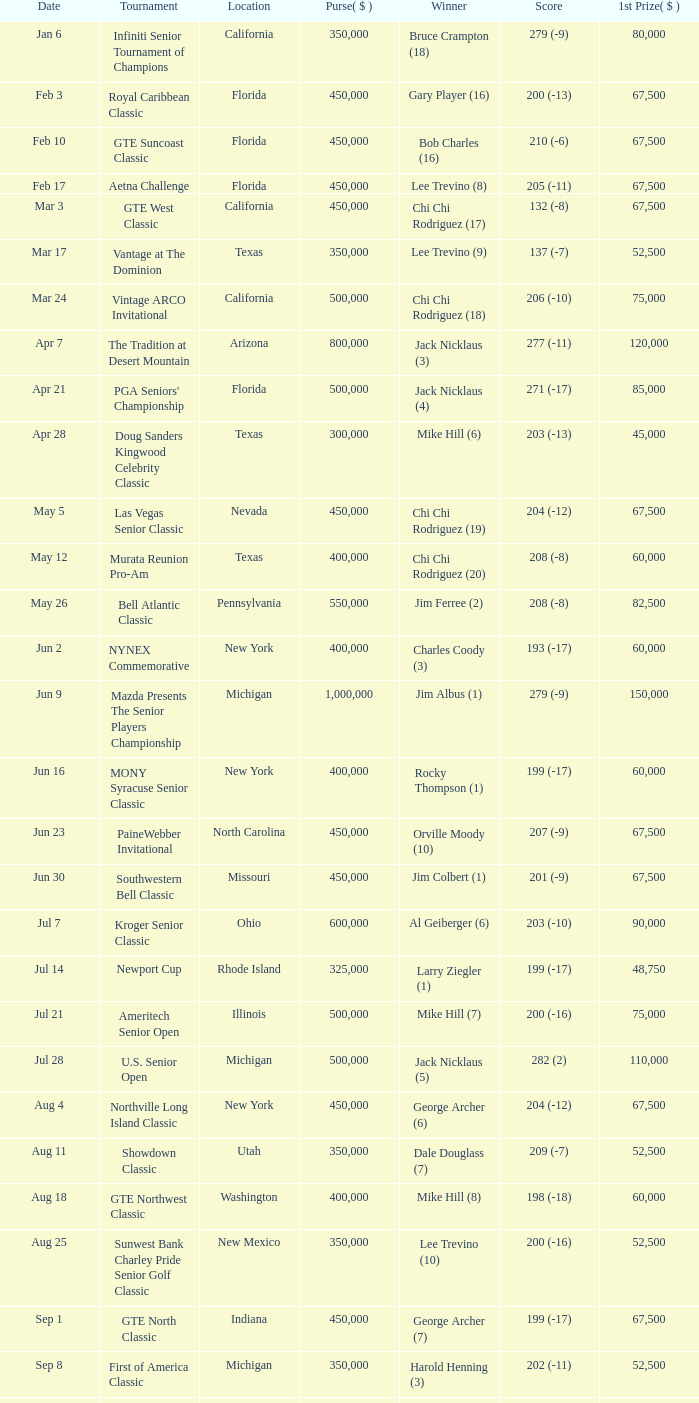What is the purse for the tournament with a winning score of 212 (-4), and a 1st prize of under $105,000? None. 